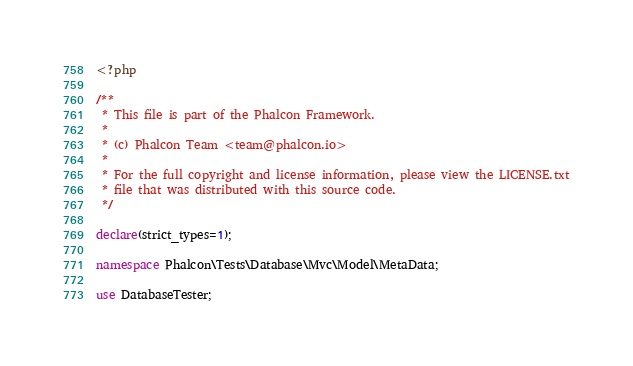Convert code to text. <code><loc_0><loc_0><loc_500><loc_500><_PHP_><?php

/**
 * This file is part of the Phalcon Framework.
 *
 * (c) Phalcon Team <team@phalcon.io>
 *
 * For the full copyright and license information, please view the LICENSE.txt
 * file that was distributed with this source code.
 */

declare(strict_types=1);

namespace Phalcon\Tests\Database\Mvc\Model\MetaData;

use DatabaseTester;</code> 